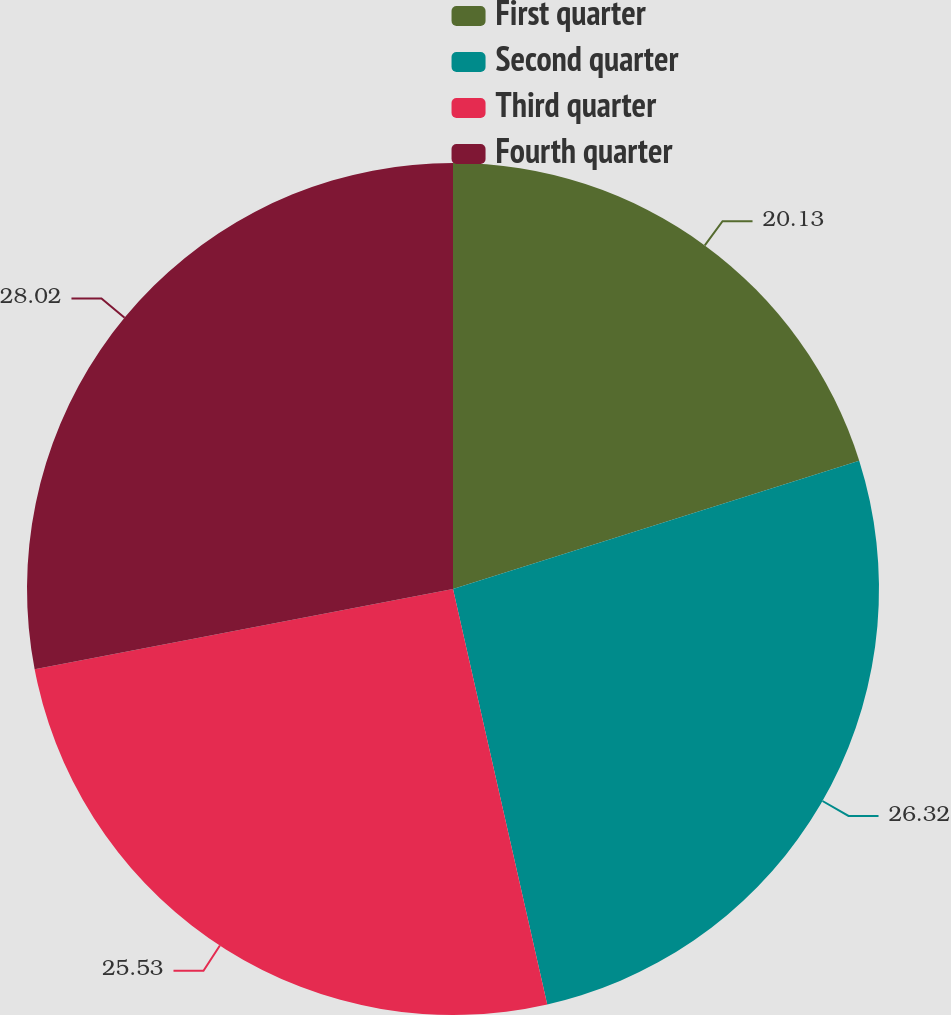Convert chart. <chart><loc_0><loc_0><loc_500><loc_500><pie_chart><fcel>First quarter<fcel>Second quarter<fcel>Third quarter<fcel>Fourth quarter<nl><fcel>20.13%<fcel>26.32%<fcel>25.53%<fcel>28.02%<nl></chart> 